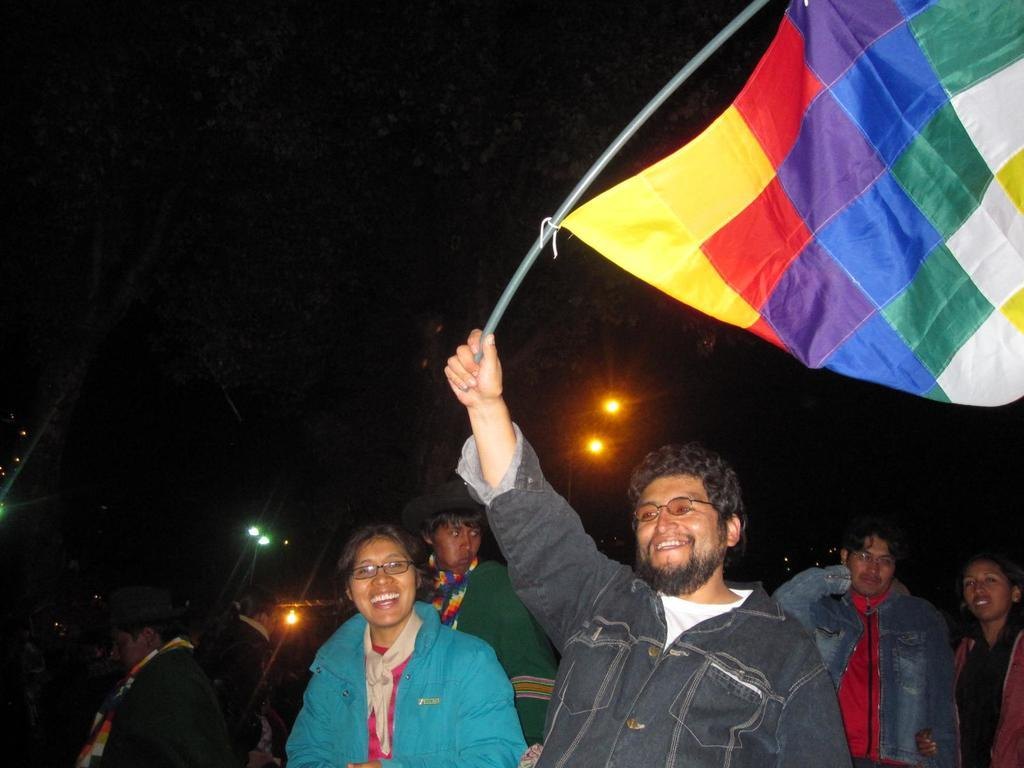Who or what is present in the image? There are people in the image. What are the people doing in the image? The people are smiling. What can be observed about the background of the image? The background of the image is dark. What else can be seen in the image besides the people? There are lights visible in the image. Where is the pail located in the image? There is no pail present in the image. What type of doll is sitting on the people's laps in the image? There is no doll present in the image. 